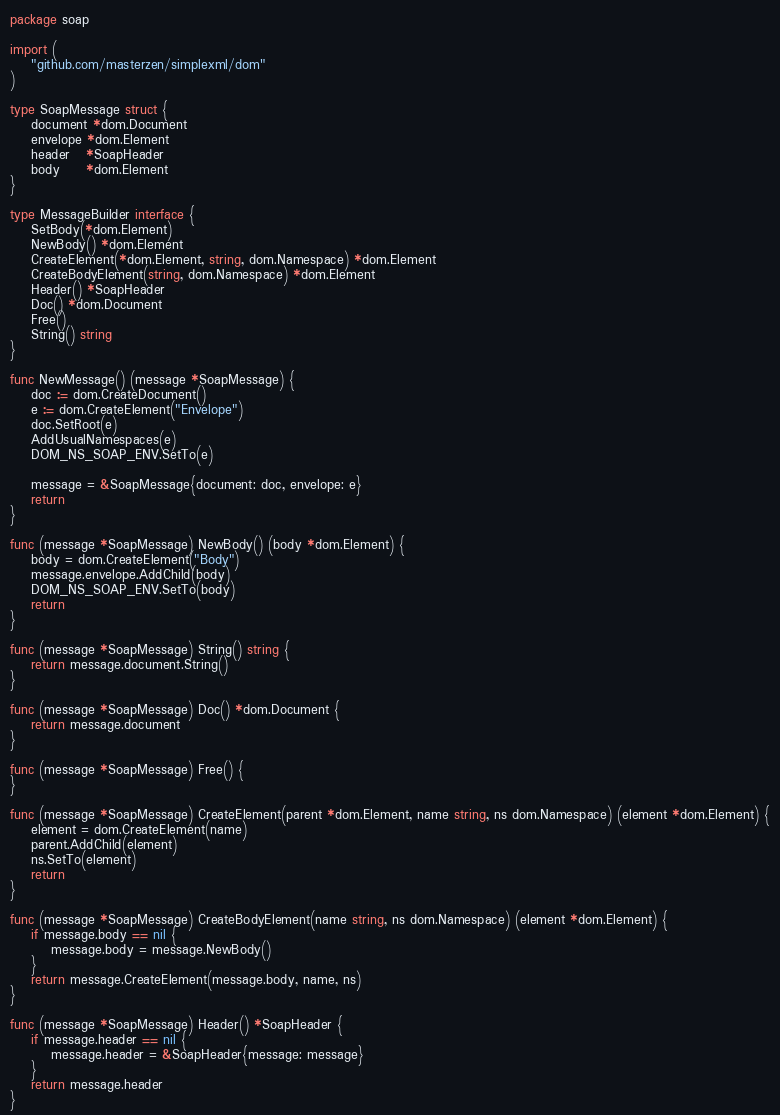<code> <loc_0><loc_0><loc_500><loc_500><_Go_>package soap

import (
	"github.com/masterzen/simplexml/dom"
)

type SoapMessage struct {
	document *dom.Document
	envelope *dom.Element
	header   *SoapHeader
	body     *dom.Element
}

type MessageBuilder interface {
	SetBody(*dom.Element)
	NewBody() *dom.Element
	CreateElement(*dom.Element, string, dom.Namespace) *dom.Element
	CreateBodyElement(string, dom.Namespace) *dom.Element
	Header() *SoapHeader
	Doc() *dom.Document
	Free()
	String() string
}

func NewMessage() (message *SoapMessage) {
	doc := dom.CreateDocument()
	e := dom.CreateElement("Envelope")
	doc.SetRoot(e)
	AddUsualNamespaces(e)
	DOM_NS_SOAP_ENV.SetTo(e)

	message = &SoapMessage{document: doc, envelope: e}
	return
}

func (message *SoapMessage) NewBody() (body *dom.Element) {
	body = dom.CreateElement("Body")
	message.envelope.AddChild(body)
	DOM_NS_SOAP_ENV.SetTo(body)
	return
}

func (message *SoapMessage) String() string {
	return message.document.String()
}

func (message *SoapMessage) Doc() *dom.Document {
	return message.document
}

func (message *SoapMessage) Free() {
}

func (message *SoapMessage) CreateElement(parent *dom.Element, name string, ns dom.Namespace) (element *dom.Element) {
	element = dom.CreateElement(name)
	parent.AddChild(element)
	ns.SetTo(element)
	return
}

func (message *SoapMessage) CreateBodyElement(name string, ns dom.Namespace) (element *dom.Element) {
	if message.body == nil {
		message.body = message.NewBody()
	}
	return message.CreateElement(message.body, name, ns)
}

func (message *SoapMessage) Header() *SoapHeader {
	if message.header == nil {
		message.header = &SoapHeader{message: message}
	}
	return message.header
}
</code> 